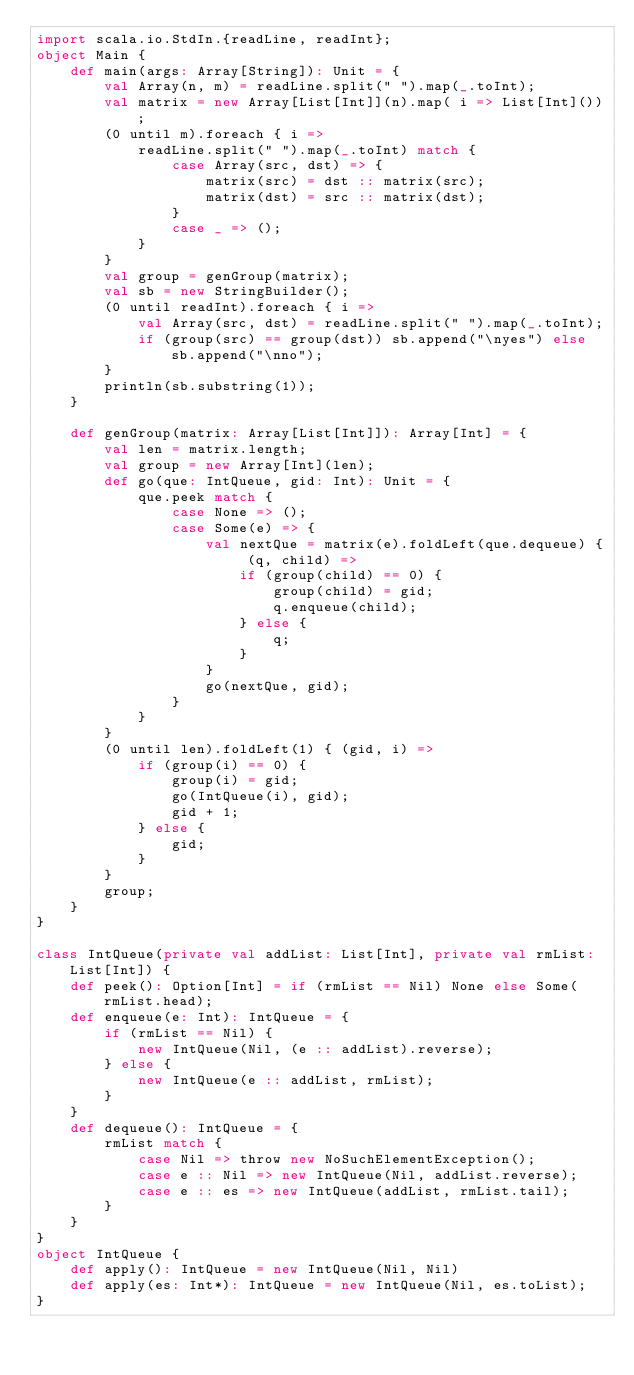Convert code to text. <code><loc_0><loc_0><loc_500><loc_500><_Scala_>import scala.io.StdIn.{readLine, readInt};
object Main {
    def main(args: Array[String]): Unit = {
        val Array(n, m) = readLine.split(" ").map(_.toInt);
        val matrix = new Array[List[Int]](n).map( i => List[Int]());
        (0 until m).foreach { i =>
            readLine.split(" ").map(_.toInt) match {
                case Array(src, dst) => {
                    matrix(src) = dst :: matrix(src);
                    matrix(dst) = src :: matrix(dst);
                }
                case _ => ();
            }
        }
        val group = genGroup(matrix);
        val sb = new StringBuilder();
        (0 until readInt).foreach { i =>
            val Array(src, dst) = readLine.split(" ").map(_.toInt);
            if (group(src) == group(dst)) sb.append("\nyes") else sb.append("\nno");
        }
        println(sb.substring(1));
    }
    
    def genGroup(matrix: Array[List[Int]]): Array[Int] = {
        val len = matrix.length;
        val group = new Array[Int](len);
        def go(que: IntQueue, gid: Int): Unit = {
            que.peek match {
                case None => ();
                case Some(e) => {
                    val nextQue = matrix(e).foldLeft(que.dequeue) { (q, child) =>
                        if (group(child) == 0) {
                            group(child) = gid;
                            q.enqueue(child);
                        } else {
                            q;
                        }
                    }
                    go(nextQue, gid);
                }
            }
        }
        (0 until len).foldLeft(1) { (gid, i) =>
            if (group(i) == 0) {
                group(i) = gid;
                go(IntQueue(i), gid);
                gid + 1;
            } else {
                gid;
            }
        }
        group;
    }
}

class IntQueue(private val addList: List[Int], private val rmList: List[Int]) {
    def peek(): Option[Int] = if (rmList == Nil) None else Some(rmList.head);
    def enqueue(e: Int): IntQueue = {
        if (rmList == Nil) {
            new IntQueue(Nil, (e :: addList).reverse);
        } else {
            new IntQueue(e :: addList, rmList);
        }
    }
    def dequeue(): IntQueue = {
        rmList match {
            case Nil => throw new NoSuchElementException();
            case e :: Nil => new IntQueue(Nil, addList.reverse);
            case e :: es => new IntQueue(addList, rmList.tail);
        }
    }
}
object IntQueue {
    def apply(): IntQueue = new IntQueue(Nil, Nil)
    def apply(es: Int*): IntQueue = new IntQueue(Nil, es.toList);
}
</code> 